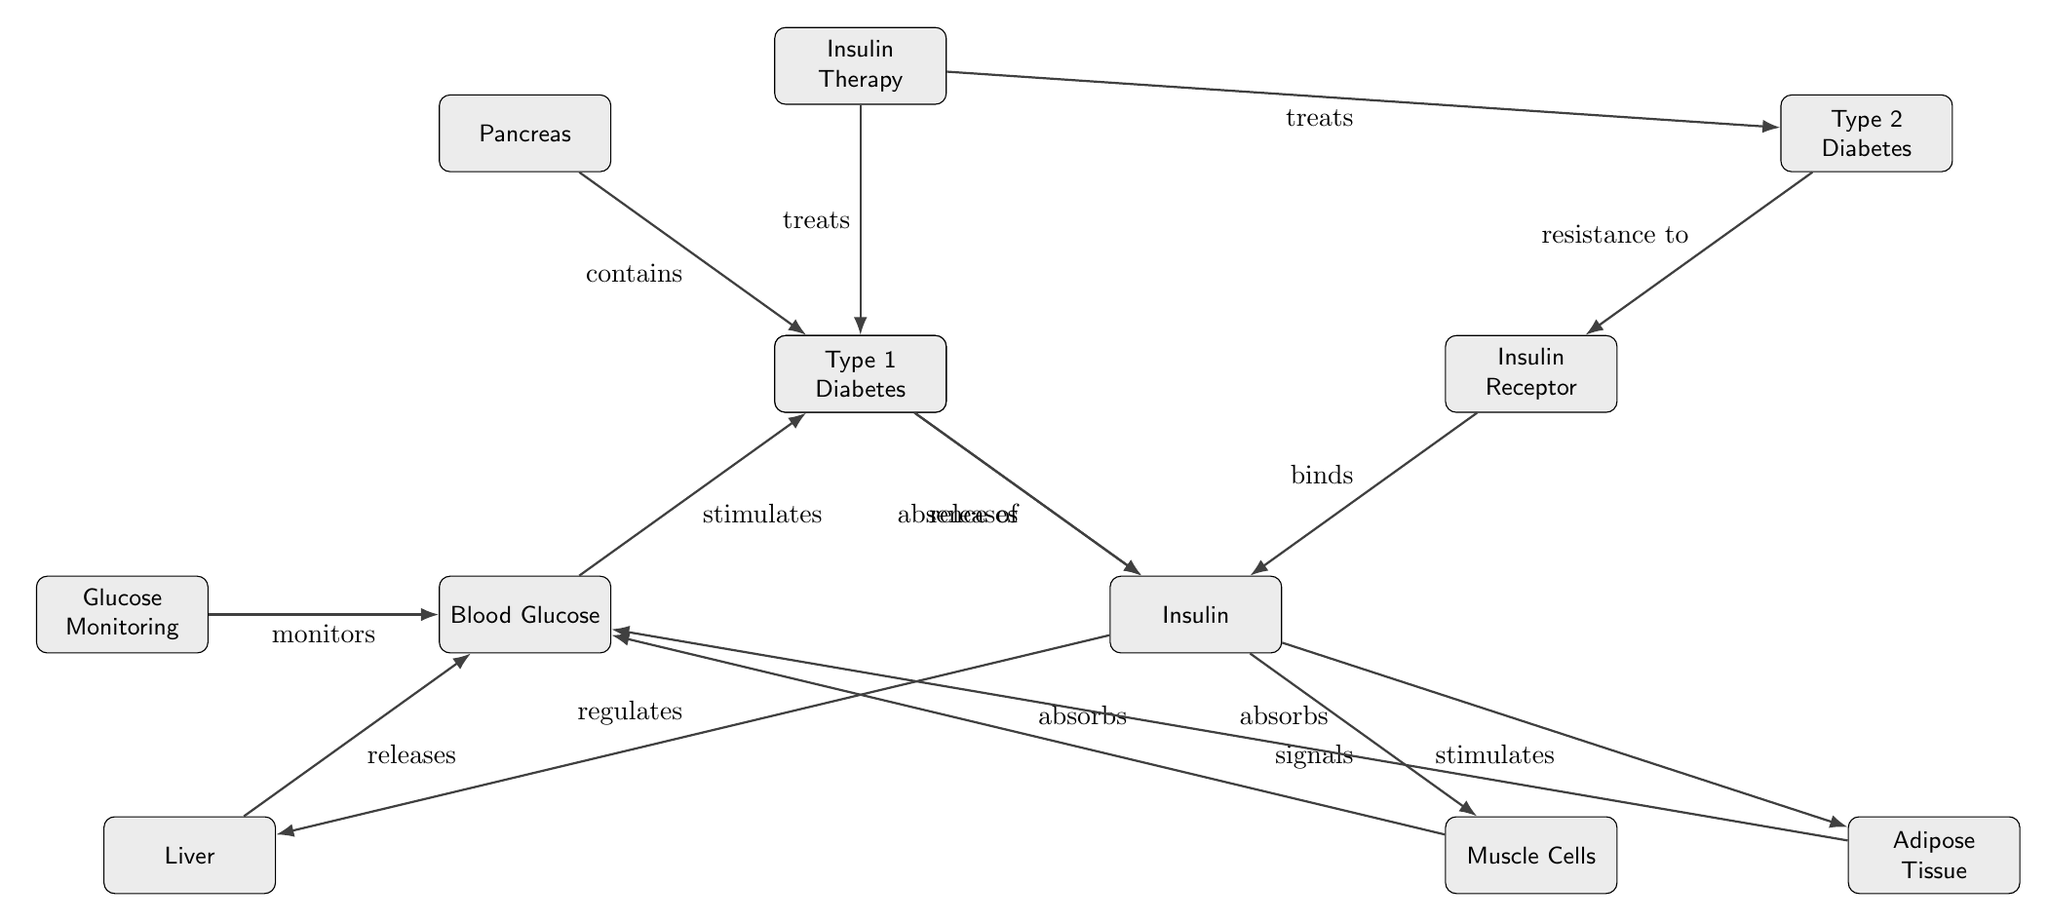What is the source of insulin production? The diagram shows that the pancreas is where insulin is produced, as indicated by the node structure where the "Pancreas" is connected to "Beta Cells," which release insulin.
Answer: Pancreas How many types of diabetes are shown in the diagram? The diagram includes two types of diabetes shown by nodes: "Type 1 Diabetes" and "Type 2 Diabetes." Therefore, counting these gives a total of two types.
Answer: 2 What stimulates insulin release? The diagram presents "Blood Glucose" as the element that stimulates the release of insulin from the "Beta Cells," as represented by the directed edge connecting these two nodes.
Answer: Blood Glucose What does insulin signal to in muscle cells? According to the diagram, insulin signals to "Muscle Cells," as shown by the direct connection originating from the insulin node to the muscle cells node.
Answer: Muscle Cells What binding occurs between insulin and another component in this diagram? The diagram illustrates that the "Insulin Receptor" binds to "Insulin," which is depicted by the direct edge linking these two nodes with the action labeled as "binds."
Answer: Insulin Receptor What regulates blood glucose levels according to the diagram? The diagram indicates that "Insulin" regulates blood glucose levels, as denoted by the edge from "Insulin" to "Liver," which releases glucose into the bloodstream, thus affecting blood glucose levels.
Answer: Insulin What is the role of insulin therapy as depicted in the diagram? The diagram shows that "Insulin Therapy" treats both "Type 1 Diabetes" and "Type 2 Diabetes," indicating that it serves a therapeutic role for managing these conditions.
Answer: Treats What happens in the absence of insulin according to the diagram? The diagram specifically states that in "Type 1 Diabetes," there is an absence of insulin, indicating the relationship shown which highlights the problem this type of diabetes presents.
Answer: Absence of Insulin How do muscle cells absorb glucose as per the diagram? The diagram illustrates that muscle cells "absorb" glucose as a response to the signal from insulin, which is indicated by the directed edge leading from insulin to muscle cells.
Answer: Absorbs What is the relationship between glucose monitoring and blood glucose levels? The diagram shows a direct connection indicating that "Glucose Monitoring" monitors "Blood Glucose," implying a relationship where monitoring is meant to keep track of glucose levels in the blood.
Answer: Monitors 